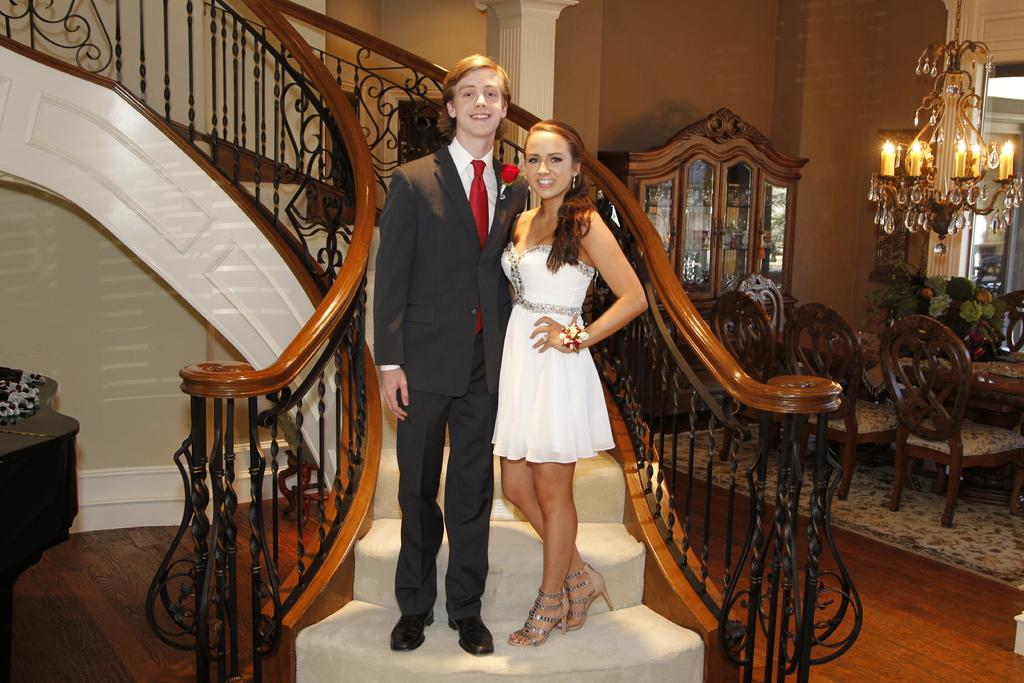How many people are in the image? There are two persons in the image. Where are the persons located in the image? The persons are standing on a staircase. What is the facial expression of the persons in the image? The persons are smiling. What type of furniture can be seen in the image? There is a table, a pillar, a wall, a dressing table, and a dining table in the image. What type of lighting is present in the image? There are lights and a candle in the image. What type of berry is being used as a decoration on the dining table in the image? There is no berry present on the dining table in the image. What idea did the persons have that led them to stand on the staircase in the image? The image does not provide any information about the persons' ideas or reasons for standing on the staircase. 